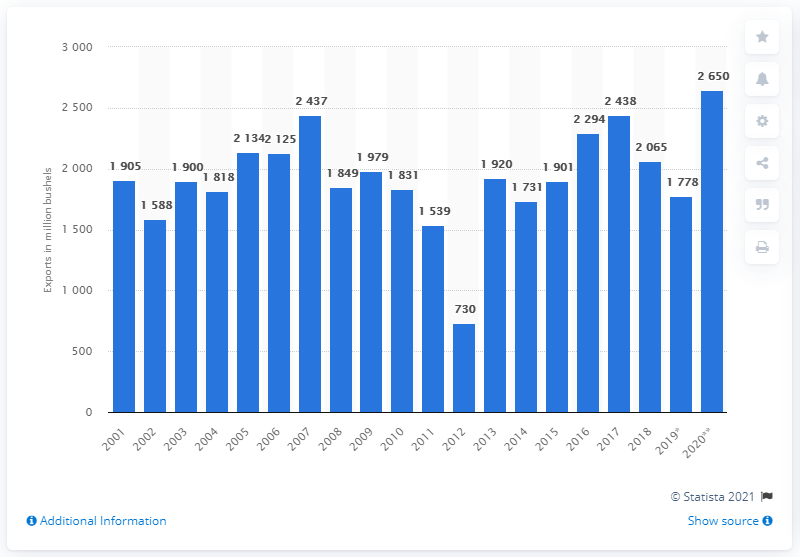Mention a couple of crucial points in this snapshot. In the year 2016, the United States was the largest producer of corn worldwide. In the year 2001, a significant amount of corn was exported from the United States, with the exact quantity being 1901 bushels. 